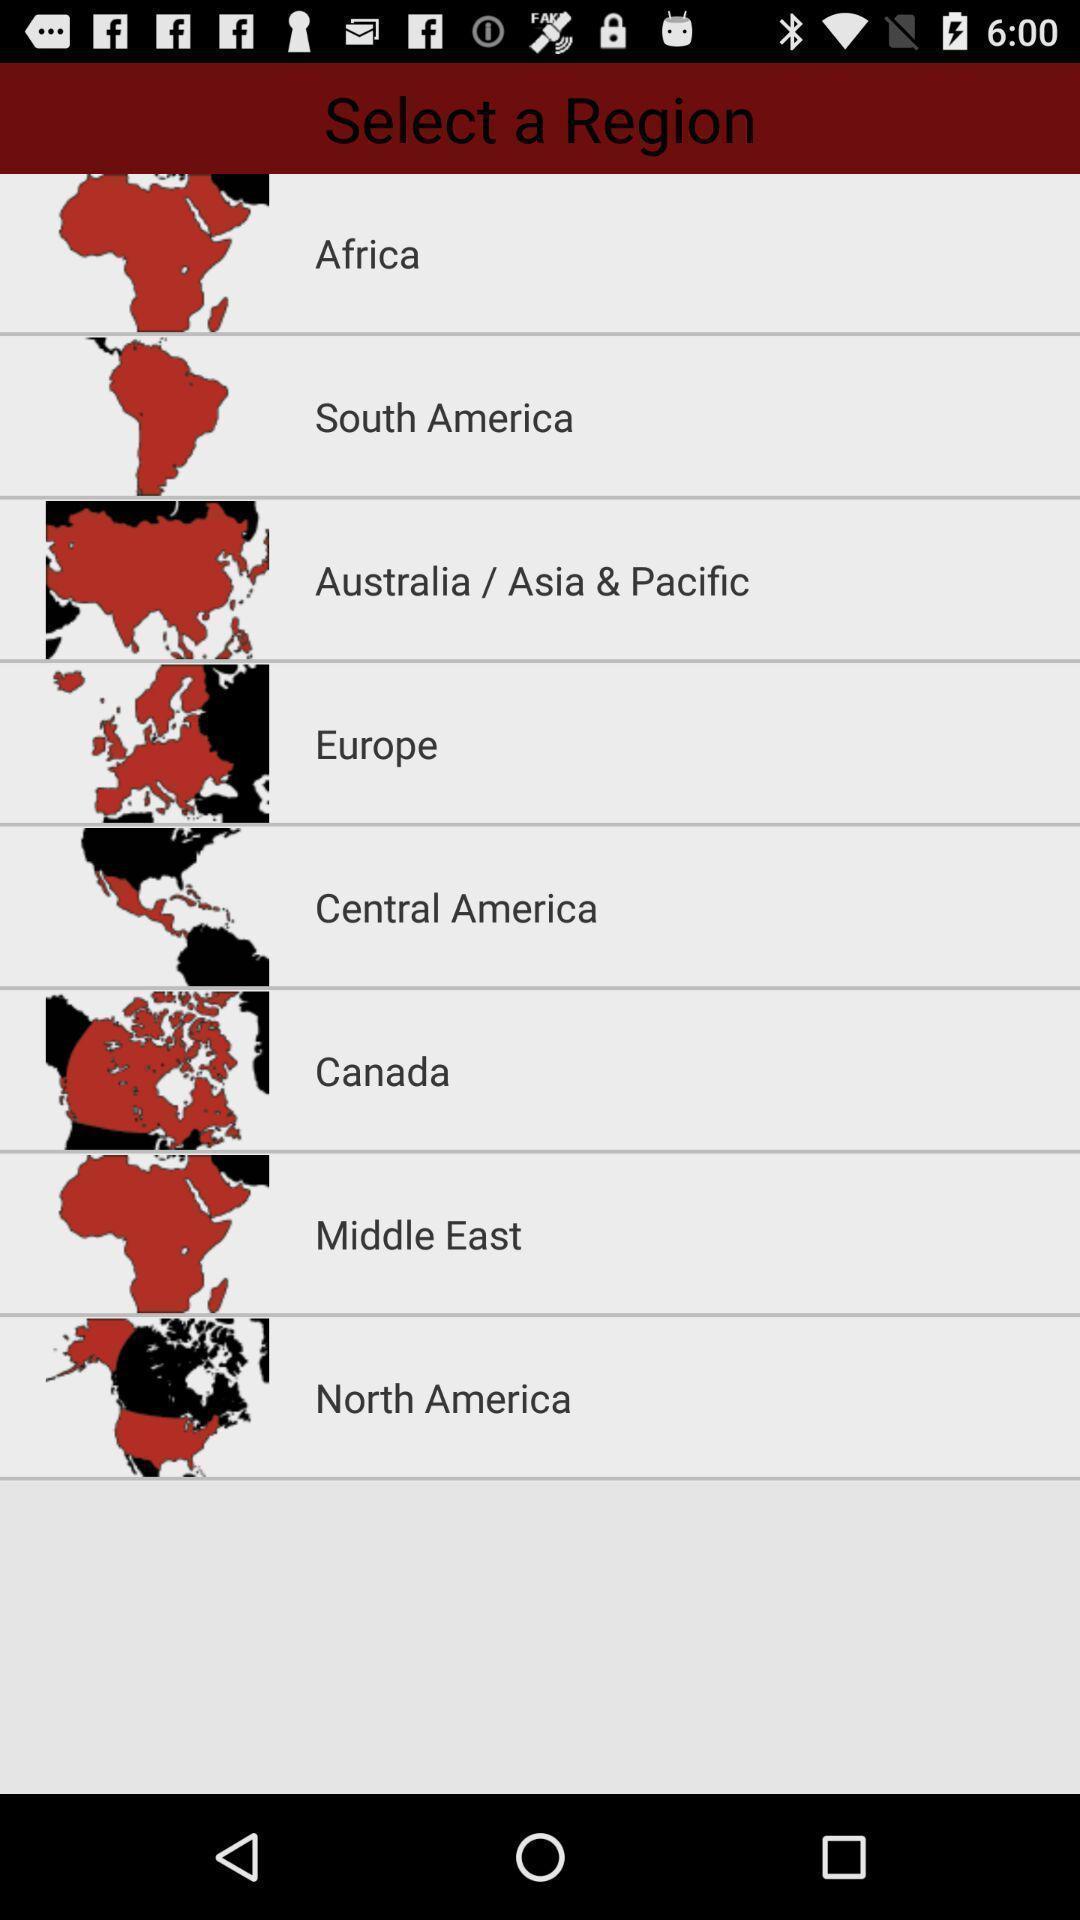What details can you identify in this image? Screen shows list of region. 